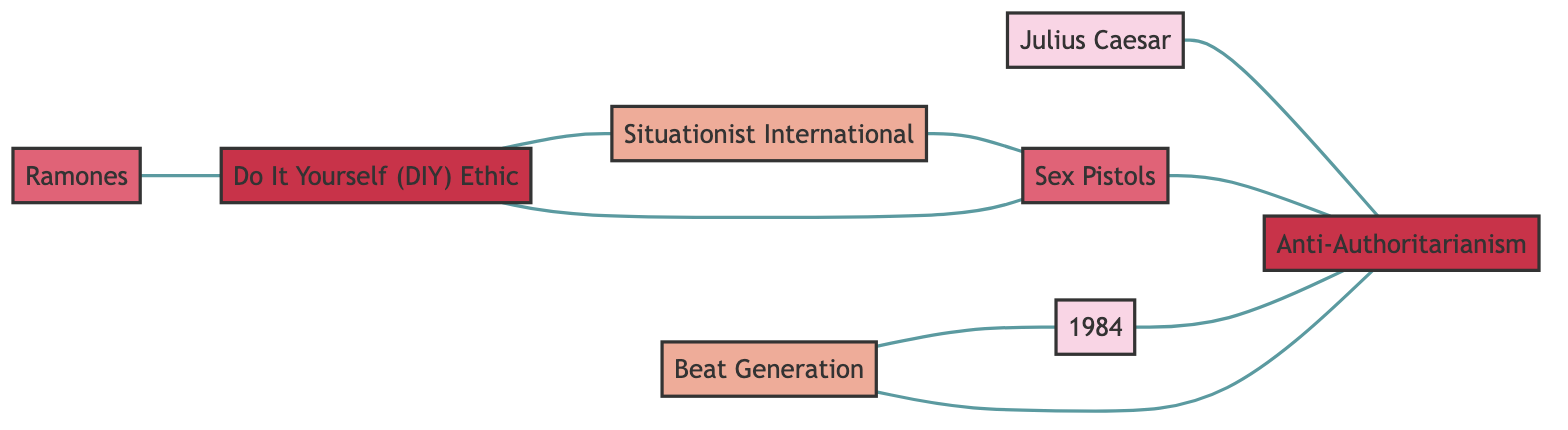What is the number of literary works represented in the diagram? The diagram includes two nodes identified as literary works: "Julius Caesar" and "1984". Therefore, the total count is 2.
Answer: 2 Which band is directly influenced by the Situationist International? The edge between "Situationist International" and "Sex Pistols" indicates an influence relationship, meaning the "Sex Pistols" are the band directly influenced by the "Situationist International".
Answer: Sex Pistols What concept is linked to both the Beat Generation and Anti-Authoritarianism? The "Beat Generation" has an edge to "Anti-Authoritarianism" showing a literary expression relationship, linking these two.
Answer: Anti-Authoritarianism How many edges connect the Do It Yourself (DIY) Ethic to other nodes? The "Do It Yourself (DIY) Ethic" has three edges—one connecting to "Situationist International", one to "Sex Pistols", and one to "Ramones". Thus, the count is 3.
Answer: 3 Which literary work shares a theme with the Anti-Authoritarianism concept? The edge between "1984" and "Anti-Authoritarianism" denotes a thematic connection, therefore, the literary work that shares this theme is "1984".
Answer: 1984 Which punk rock band practices the Do It Yourself (DIY) Ethic? The edge from "Ramones" to "Do It Yourself (DIY) Ethic" indicates that this punk rock band engages in DIY practices.
Answer: Ramones What relationship exists between the Beat Generation and the literary work 1984? The relationship between "Beat Generation" and "1984" is characterized as "Inspirational Contrast", indicating a contrasting influence.
Answer: Inspirational Contrast List all nodes that are categorized as concepts. The diagram has two concept nodes: "Anti-Authoritarianism" and "Do It Yourself (DIY) Ethic". Therefore, the list includes these two nodes.
Answer: Anti-Authoritarianism, Do It Yourself (DIY) Ethic What type of movement is the Situationist International? The "Situationist International" is classified as a movement, indicating its role within the context of political and philosophical themes.
Answer: Movement 